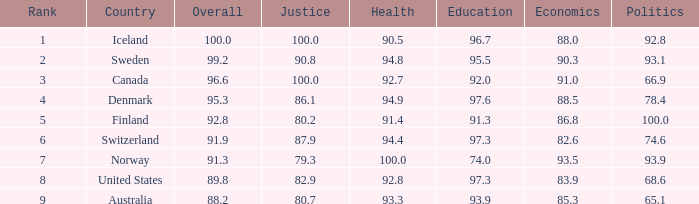What's the economic evaluation with education being 9 91.0. 